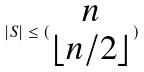<formula> <loc_0><loc_0><loc_500><loc_500>| S | \leq ( \begin{matrix} n \\ \lfloor n / 2 \rfloor \end{matrix} )</formula> 